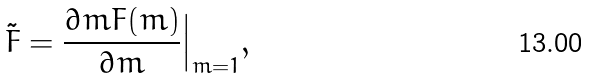<formula> <loc_0><loc_0><loc_500><loc_500>\tilde { F } = \frac { \partial m F ( m ) } { \partial m } \Big | _ { m = 1 } ,</formula> 